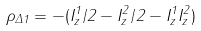Convert formula to latex. <formula><loc_0><loc_0><loc_500><loc_500>\rho _ { \Delta 1 } = - ( I _ { z } ^ { 1 } / 2 - I _ { z } ^ { 2 } / 2 - I _ { z } ^ { 1 } I _ { z } ^ { 2 } )</formula> 